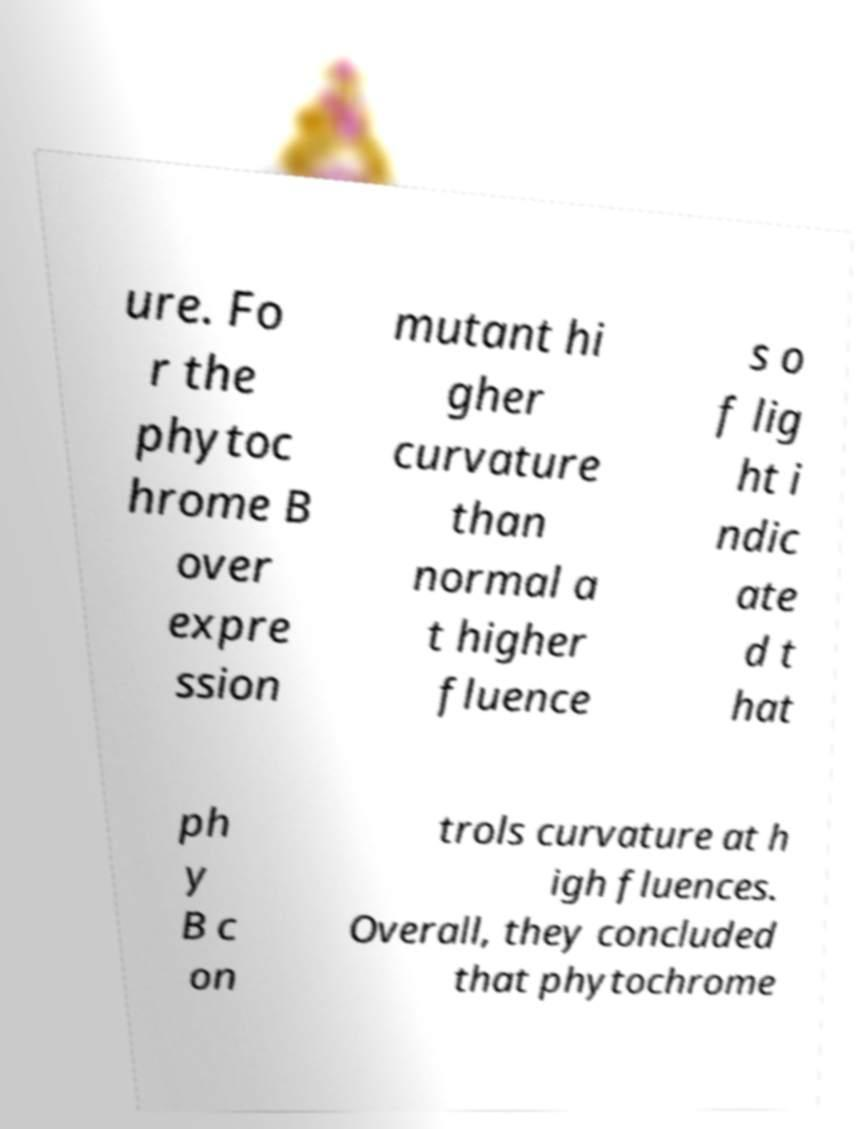Please read and relay the text visible in this image. What does it say? ure. Fo r the phytoc hrome B over expre ssion mutant hi gher curvature than normal a t higher fluence s o f lig ht i ndic ate d t hat ph y B c on trols curvature at h igh fluences. Overall, they concluded that phytochrome 